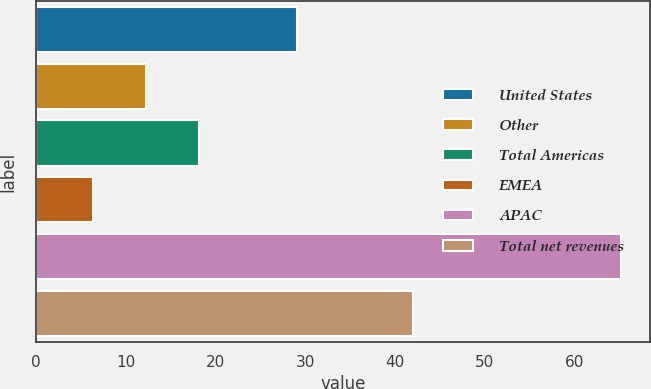Convert chart. <chart><loc_0><loc_0><loc_500><loc_500><bar_chart><fcel>United States<fcel>Other<fcel>Total Americas<fcel>EMEA<fcel>APAC<fcel>Total net revenues<nl><fcel>29.1<fcel>12.3<fcel>18.18<fcel>6.4<fcel>65.2<fcel>42<nl></chart> 